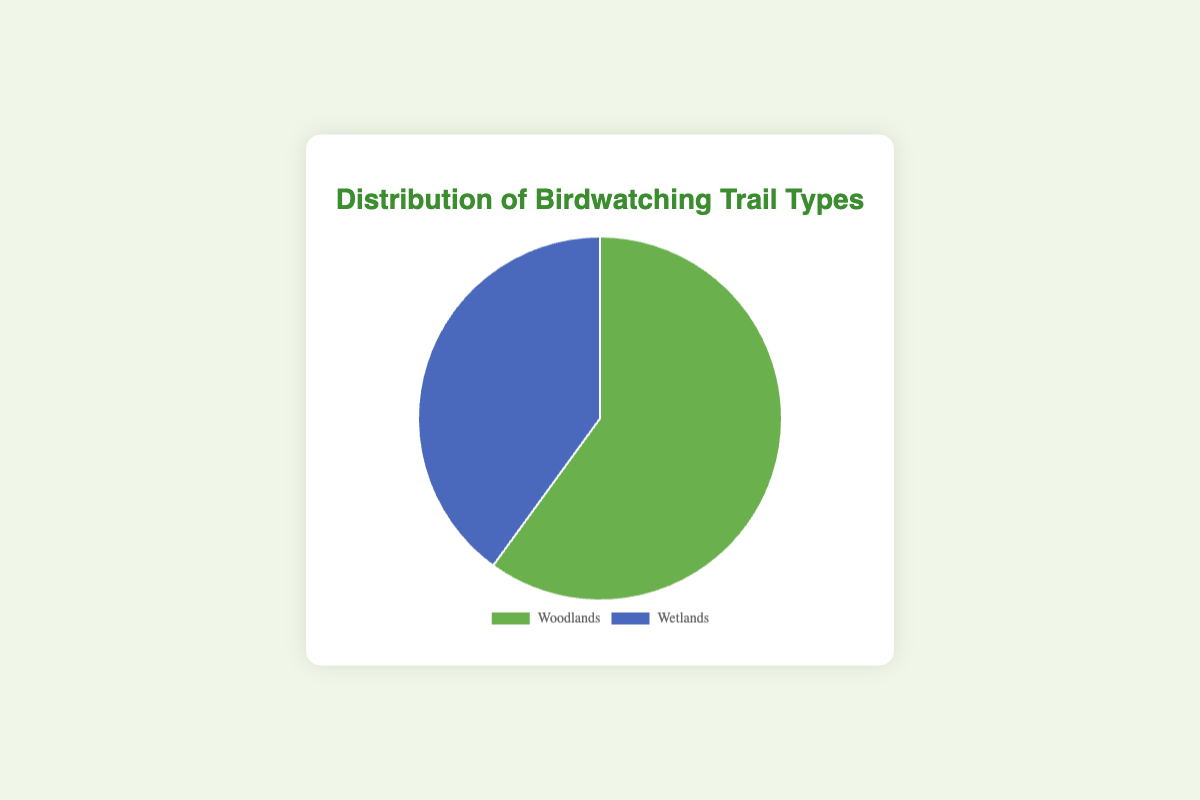What percentage of birdwatching trails are woodlands? According to the data shown in the pie chart, the woodlands make up 60% of the birdwatching trails.
Answer: 60% What is the difference in percentage between the woodlands and wetlands trails? The woodlands trail type is at 60%, and the wetlands trail type is at 40%. The difference between them is 60% - 40%.
Answer: 20% If there are 100 trails in total, how many of them are wetlands? If wetlands account for 40% of the total trails, and there are 100 trails, then the number of wetlands trails is 100 * 0.40 = 40.
Answer: 40 Which trail type is used more for birdwatching? The pie chart shows that woodlands account for 60% and wetlands for 40%. Therefore, woodlands are used more.
Answer: Woodlands What fraction of the trails are wetlands? Wetlands make up 40% of the trails. To convert this percentage to a fraction, we write 40% as 40/100, which simplifies to 2/5.
Answer: 2/5 What color represents the woodland trails in the chart? The pie chart has the woodlands trails colored in a shade of green.
Answer: Green If the woodlands percentage were to increase by 10% and from wetlands decrease by 10%, what would the new percentages be? Adding 10% to the woodlands percentage would make it 60% + 10% = 70%. Subtracting 10% from the wetlands percentage would make it 40% - 10% = 30%.
Answer: 70% woodlands, 30% wetlands Together, what is the combined percentage of woodlands and wetlands trails? The combined percentage of both woodlands and wetlands trails is 60% + 40% according to the pie chart.
Answer: 100% What is the smallest segment's data point in the chart, and what percentage does it hold? The smallest segment in the pie chart represents the wetlands trails, which account for 40% of the total.
Answer: Wetlands, 40% 